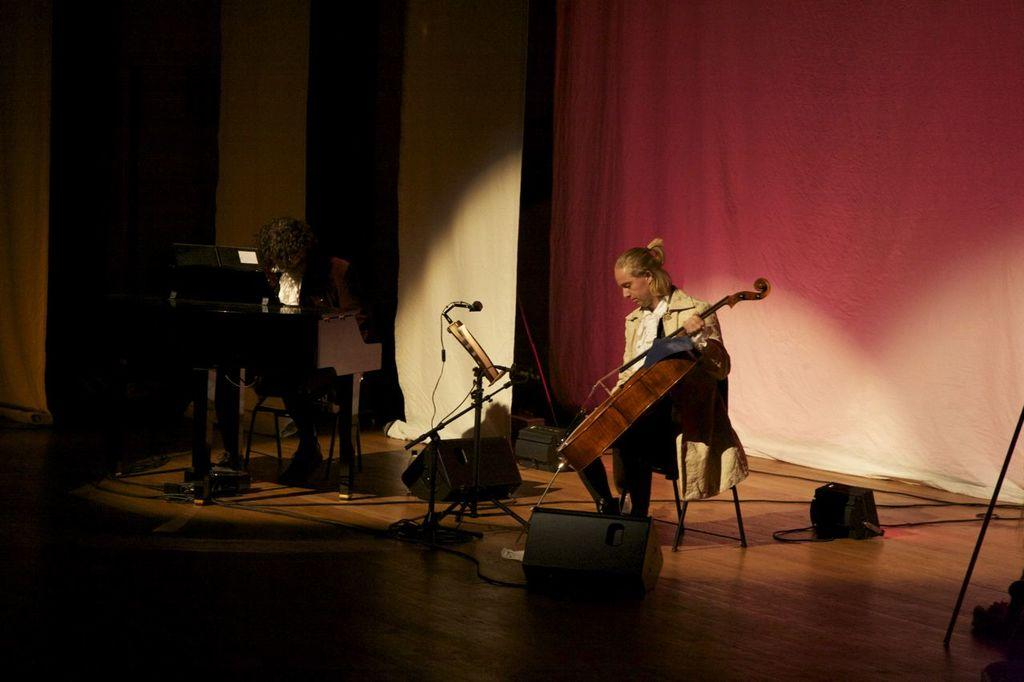How many people are in the image? There are two persons in the image. What are the persons doing in the image? The persons are sitting and holding musical instruments. Can you describe the background of the image? There is a cloth visible in the background of the image. What type of event are the persons attending in the image? There is no indication of an event in the image; it simply shows two people sitting and holding musical instruments. How many friends are visible in the image? The concept of "friends" is not mentioned in the image, as it only shows two people sitting and holding musical instruments. 